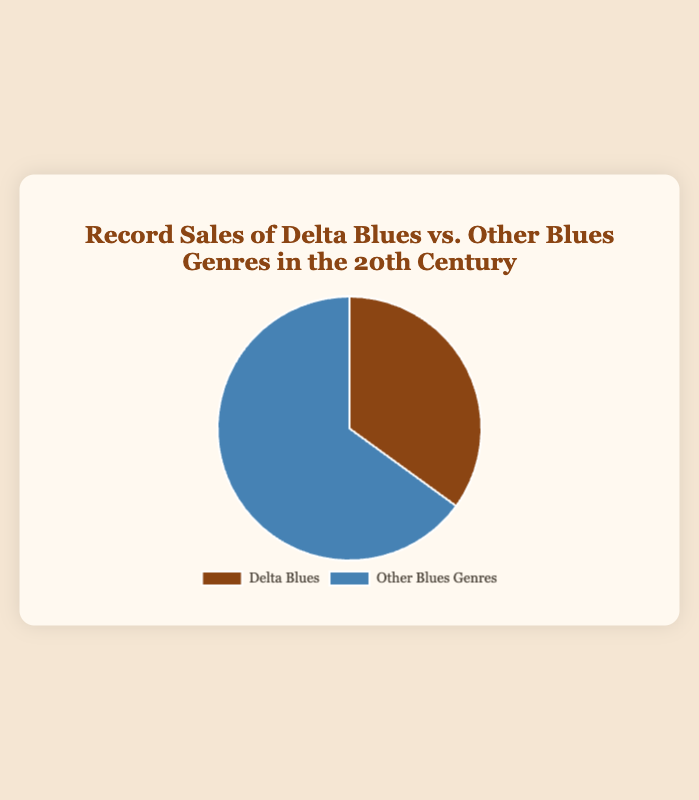How much greater are the sales of Other Blues Genres compared to Delta Blues? To determine this, subtract the sales percentage of Delta Blues from that of Other Blues Genres (65 - 35).
Answer: 30 What percentage of the total record sales do Delta Blues and Other Blues Genres represent individually? Delta Blues represents 35% of record sales, and Other Blues Genres represent 65%. These percentages are given directly in the chart's data.
Answer: Delta Blues: 35%, Other Blues: 65% What is the ratio of record sales of Delta Blues to Other Blues Genres? The ratio can be found by dividing the sales percentage of Delta Blues by the sales percentage of Other Blues Genres (35 / 65), giving approximately 0.54.
Answer: 0.54 How would you describe the visual difference between Delta Blues and Other Blues Genres in the pie chart? In the pie chart, Delta Blues is shown in brown, while Other Blues Genres are shown in blue. Other Blues Genres take up a larger portion of the pie, visually indicating that their sales percentage is higher.
Answer: Brown vs. Blue, larger portion for Other Blues Genres If the pie chart were to represent 1000 total album sales, how many would be Delta Blues and how many would be Other Blues Genres? To find this, multiply 1000 by each respective sales percentage (Delta Blues: 1000 * 0.35 = 350, Other Blues Genres: 1000 * 0.65 = 650).
Answer: Delta Blues: 350, Other Blues: 650 What is the combined percentage of record sales for Delta Blues and Other Blues Genres? To find the combined percentage, add the sales percentages of Delta Blues and Other Blues Genres (35 + 65).
Answer: 100% Which genre holds a higher percentage of record sales? The chart shows that Other Blues Genres hold a higher percentage of record sales compared to Delta Blues.
Answer: Other Blues Genres If the percentage of sales for Other Blues Genres were to decrease by 10%, what would the new percentage be? To find the new percentage, subtract 10% from the current Other Blues Genres sales percentage (65 - 10).
Answer: 55% 